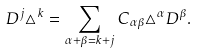Convert formula to latex. <formula><loc_0><loc_0><loc_500><loc_500>D ^ { j } \triangle ^ { k } = \sum _ { \alpha + \beta = k + j } C _ { \alpha \beta } \triangle ^ { \alpha } D ^ { \beta } .</formula> 